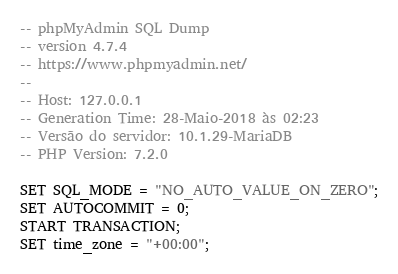<code> <loc_0><loc_0><loc_500><loc_500><_SQL_>-- phpMyAdmin SQL Dump
-- version 4.7.4
-- https://www.phpmyadmin.net/
--
-- Host: 127.0.0.1
-- Generation Time: 28-Maio-2018 às 02:23
-- Versão do servidor: 10.1.29-MariaDB
-- PHP Version: 7.2.0

SET SQL_MODE = "NO_AUTO_VALUE_ON_ZERO";
SET AUTOCOMMIT = 0;
START TRANSACTION;
SET time_zone = "+00:00";

</code> 